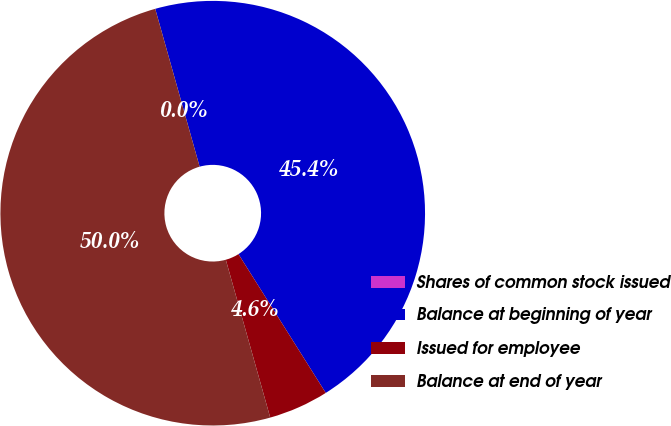Convert chart to OTSL. <chart><loc_0><loc_0><loc_500><loc_500><pie_chart><fcel>Shares of common stock issued<fcel>Balance at beginning of year<fcel>Issued for employee<fcel>Balance at end of year<nl><fcel>0.0%<fcel>45.43%<fcel>4.57%<fcel>50.0%<nl></chart> 